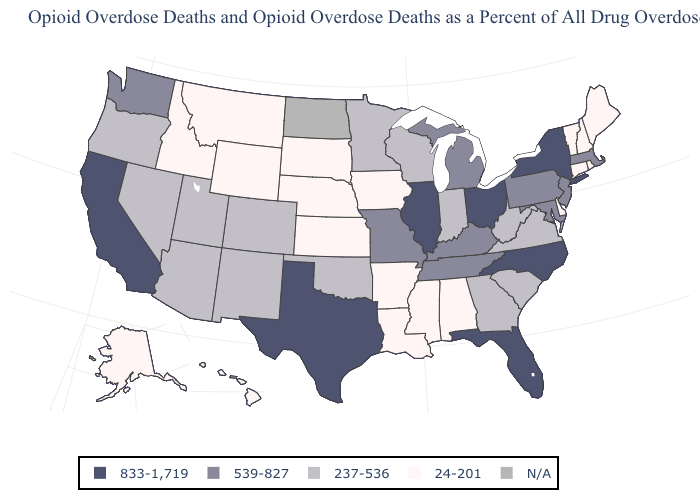Among the states that border Maine , which have the lowest value?
Quick response, please. New Hampshire. How many symbols are there in the legend?
Quick response, please. 5. What is the highest value in the USA?
Be succinct. 833-1,719. What is the value of Washington?
Give a very brief answer. 539-827. Name the states that have a value in the range N/A?
Answer briefly. North Dakota. Name the states that have a value in the range N/A?
Keep it brief. North Dakota. What is the value of Alaska?
Answer briefly. 24-201. Which states hav the highest value in the South?
Be succinct. Florida, North Carolina, Texas. What is the lowest value in the South?
Short answer required. 24-201. What is the value of Louisiana?
Short answer required. 24-201. What is the value of Alaska?
Short answer required. 24-201. Does the first symbol in the legend represent the smallest category?
Give a very brief answer. No. Among the states that border Virginia , does North Carolina have the highest value?
Short answer required. Yes. Which states hav the highest value in the Northeast?
Answer briefly. New York. 